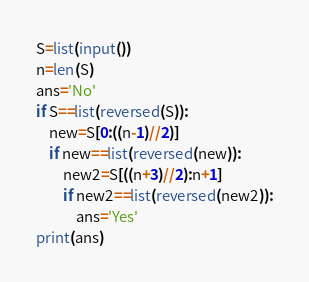Convert code to text. <code><loc_0><loc_0><loc_500><loc_500><_Python_>S=list(input())
n=len(S)
ans='No'
if S==list(reversed(S)):
    new=S[0:((n-1)//2)]
    if new==list(reversed(new)):
        new2=S[((n+3)//2):n+1]
        if new2==list(reversed(new2)):
            ans='Yes'
print(ans)</code> 